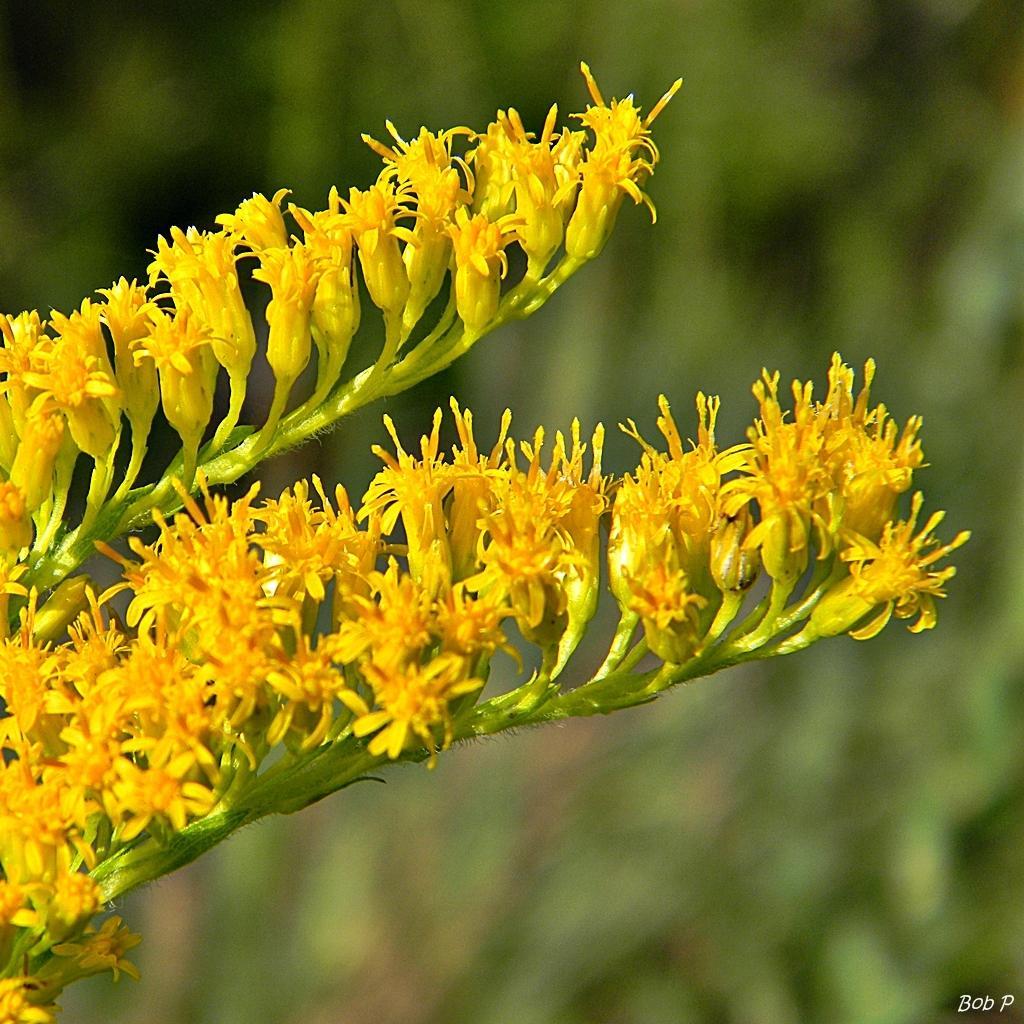Describe this image in one or two sentences. This image consists of plant. It has yellow flowers. 